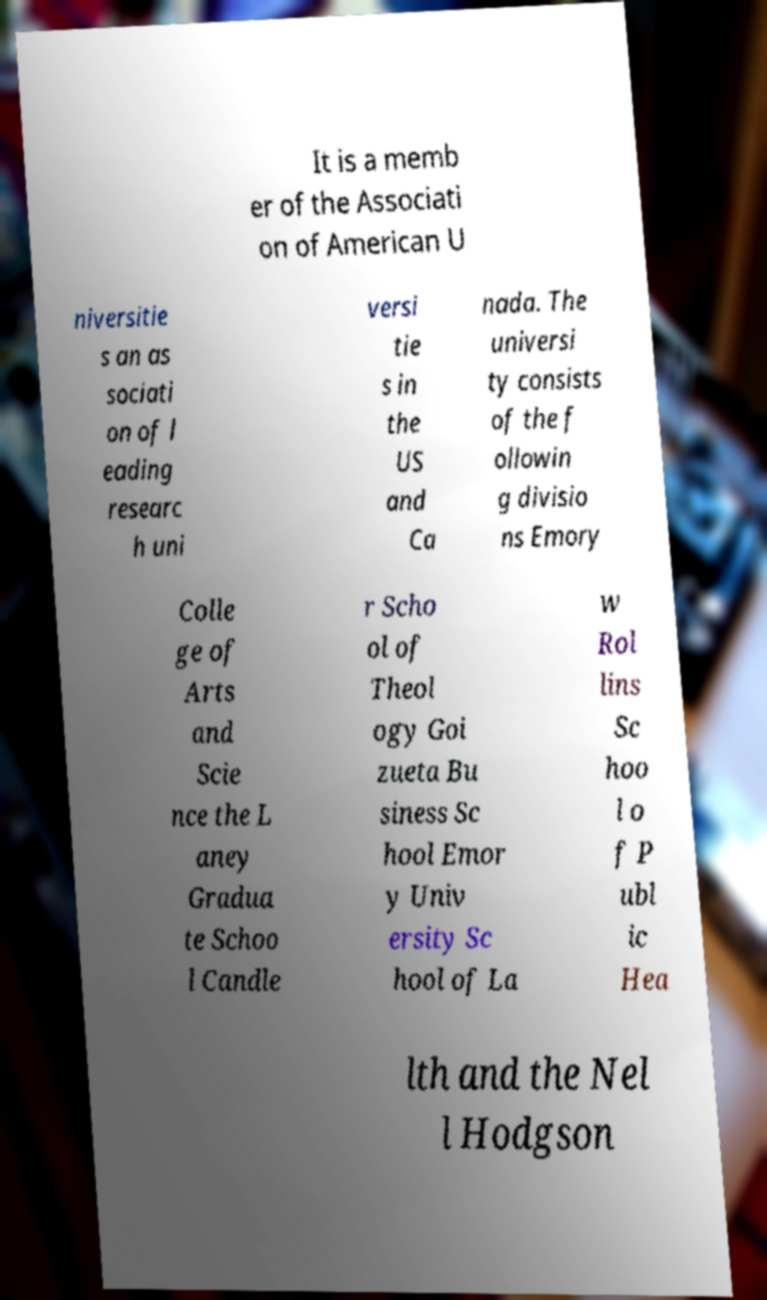Can you accurately transcribe the text from the provided image for me? It is a memb er of the Associati on of American U niversitie s an as sociati on of l eading researc h uni versi tie s in the US and Ca nada. The universi ty consists of the f ollowin g divisio ns Emory Colle ge of Arts and Scie nce the L aney Gradua te Schoo l Candle r Scho ol of Theol ogy Goi zueta Bu siness Sc hool Emor y Univ ersity Sc hool of La w Rol lins Sc hoo l o f P ubl ic Hea lth and the Nel l Hodgson 